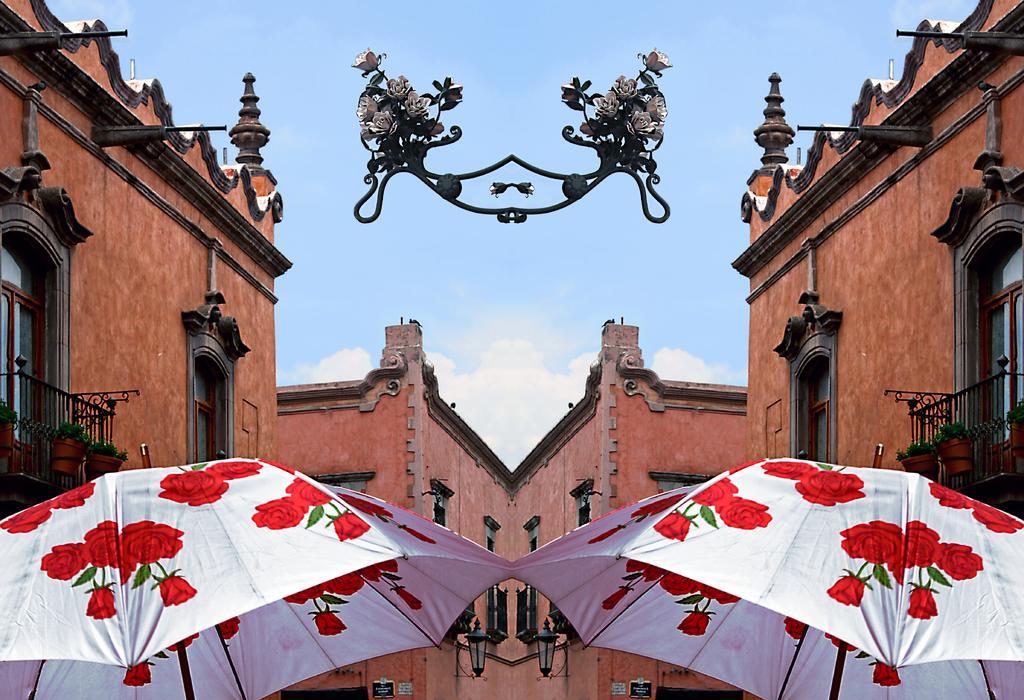Could you give a brief overview of what you see in this image? in this image we can see buildings, grills, houseplants, umbrellas and sky with clouds. 